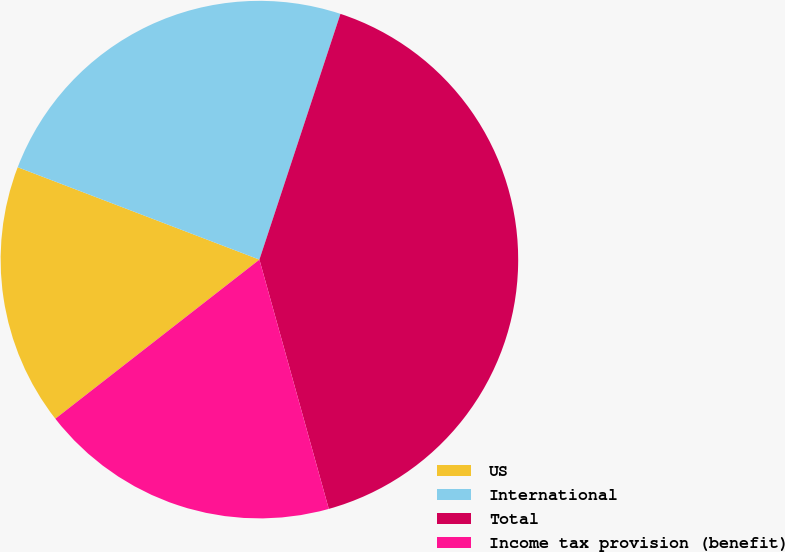Convert chart. <chart><loc_0><loc_0><loc_500><loc_500><pie_chart><fcel>US<fcel>International<fcel>Total<fcel>Income tax provision (benefit)<nl><fcel>16.35%<fcel>24.26%<fcel>40.61%<fcel>18.78%<nl></chart> 